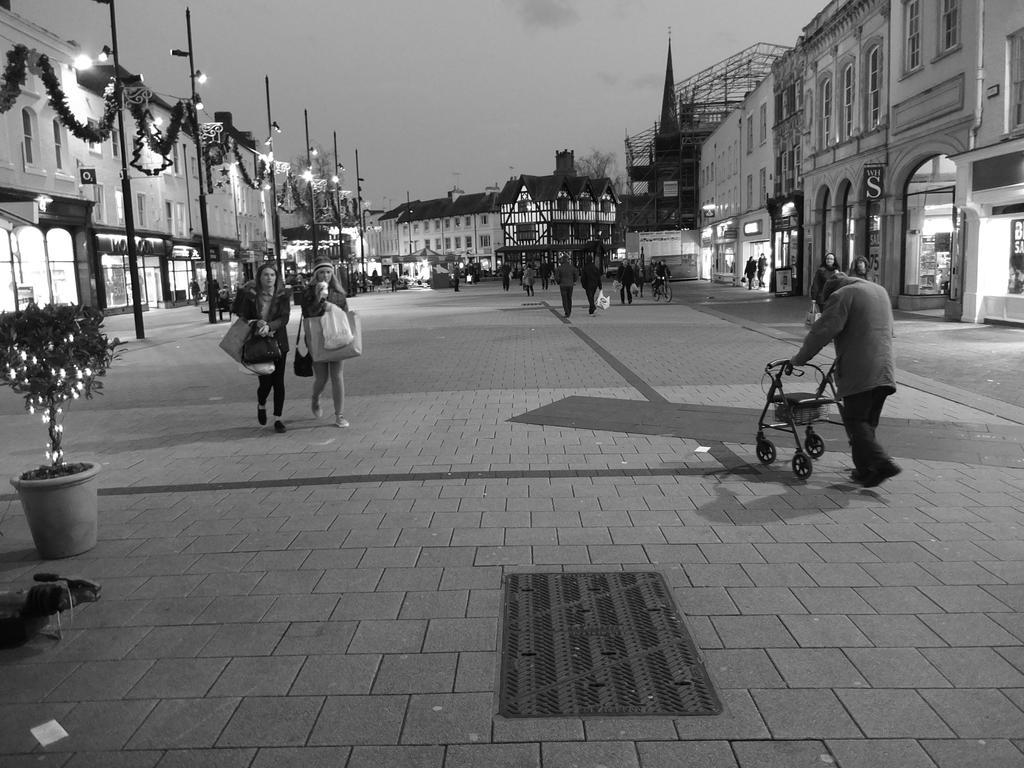Can you describe this image briefly? This is a black and white image. At the bottom, I can see the ground. On the right there is a person holding a wheelchair and walking. On the left side there is a plant along with the lights and two women are holding the bags and walking. In the background there are many buildings and light poles and also I can see many people on the ground. At the top of the image I can see the sky. 